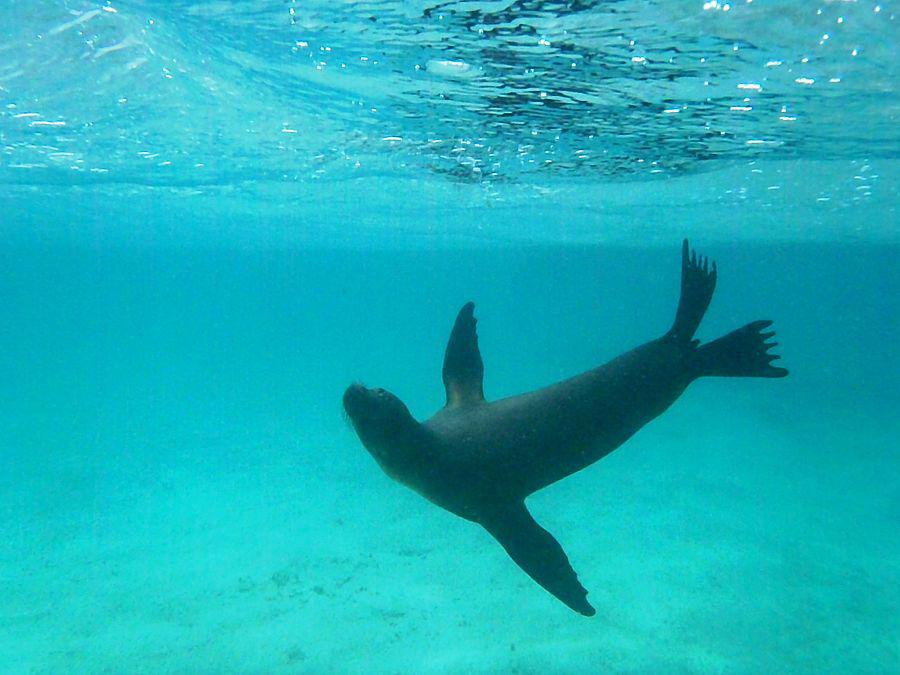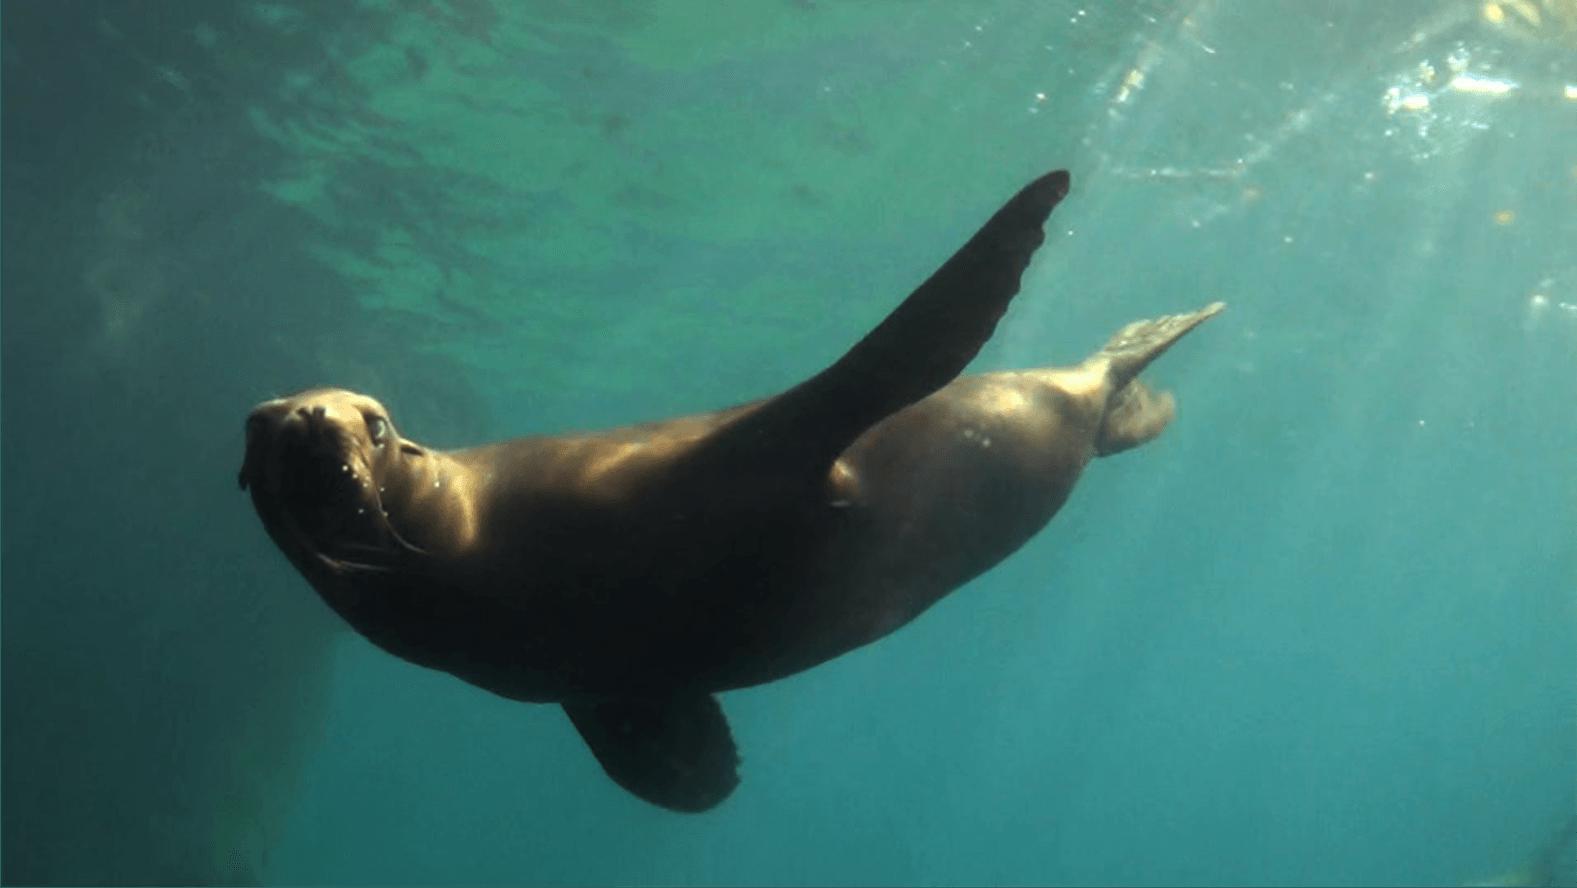The first image is the image on the left, the second image is the image on the right. For the images shown, is this caption "there are two animals total" true? Answer yes or no. Yes. The first image is the image on the left, the second image is the image on the right. Evaluate the accuracy of this statement regarding the images: "We have two seals here, swimming.". Is it true? Answer yes or no. Yes. 